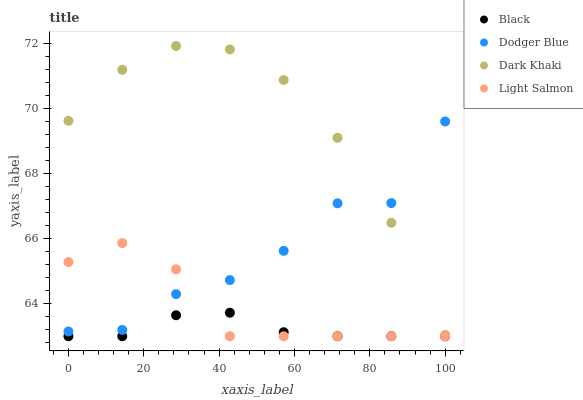Does Black have the minimum area under the curve?
Answer yes or no. Yes. Does Dark Khaki have the maximum area under the curve?
Answer yes or no. Yes. Does Dodger Blue have the minimum area under the curve?
Answer yes or no. No. Does Dodger Blue have the maximum area under the curve?
Answer yes or no. No. Is Black the smoothest?
Answer yes or no. Yes. Is Dodger Blue the roughest?
Answer yes or no. Yes. Is Light Salmon the smoothest?
Answer yes or no. No. Is Light Salmon the roughest?
Answer yes or no. No. Does Light Salmon have the lowest value?
Answer yes or no. Yes. Does Dodger Blue have the lowest value?
Answer yes or no. No. Does Dark Khaki have the highest value?
Answer yes or no. Yes. Does Dodger Blue have the highest value?
Answer yes or no. No. Is Light Salmon less than Dark Khaki?
Answer yes or no. Yes. Is Dark Khaki greater than Light Salmon?
Answer yes or no. Yes. Does Dark Khaki intersect Dodger Blue?
Answer yes or no. Yes. Is Dark Khaki less than Dodger Blue?
Answer yes or no. No. Is Dark Khaki greater than Dodger Blue?
Answer yes or no. No. Does Light Salmon intersect Dark Khaki?
Answer yes or no. No. 